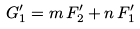<formula> <loc_0><loc_0><loc_500><loc_500>G _ { 1 } ^ { \prime } = m \, F _ { 2 } ^ { \prime } + n \, F _ { 1 } ^ { \prime }</formula> 